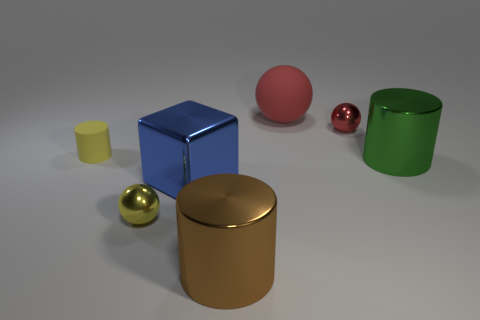What number of green things are cubes or tiny spheres?
Provide a succinct answer. 0. What size is the blue object that is on the left side of the small metal object that is right of the brown shiny object?
Offer a very short reply. Large. Does the shiny block have the same color as the metallic thing that is behind the matte cylinder?
Keep it short and to the point. No. How many other objects are the same material as the big blue block?
Provide a succinct answer. 4. There is a blue thing that is made of the same material as the large green cylinder; what shape is it?
Offer a terse response. Cube. Is there any other thing that is the same color as the large matte object?
Provide a short and direct response. Yes. What size is the metallic thing that is the same color as the tiny matte thing?
Your answer should be very brief. Small. Are there more tiny yellow matte cylinders in front of the big blue thing than small green rubber things?
Keep it short and to the point. No. There is a small rubber object; is its shape the same as the yellow thing to the right of the small yellow matte object?
Make the answer very short. No. What number of yellow matte objects are the same size as the green metallic thing?
Ensure brevity in your answer.  0. 